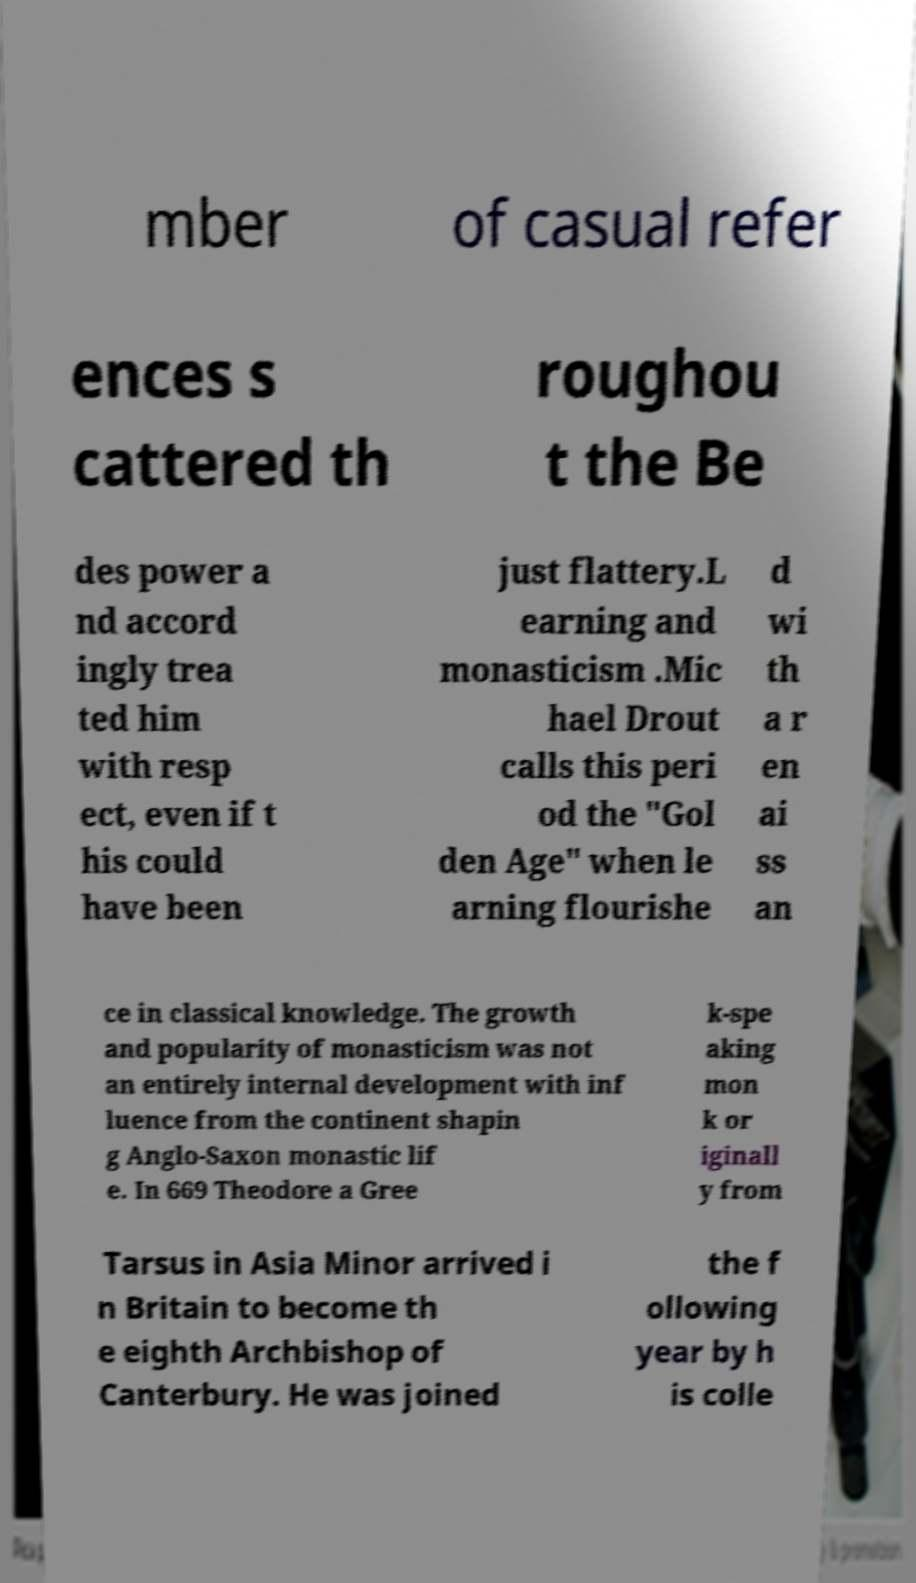Please identify and transcribe the text found in this image. mber of casual refer ences s cattered th roughou t the Be des power a nd accord ingly trea ted him with resp ect, even if t his could have been just flattery.L earning and monasticism .Mic hael Drout calls this peri od the "Gol den Age" when le arning flourishe d wi th a r en ai ss an ce in classical knowledge. The growth and popularity of monasticism was not an entirely internal development with inf luence from the continent shapin g Anglo-Saxon monastic lif e. In 669 Theodore a Gree k-spe aking mon k or iginall y from Tarsus in Asia Minor arrived i n Britain to become th e eighth Archbishop of Canterbury. He was joined the f ollowing year by h is colle 